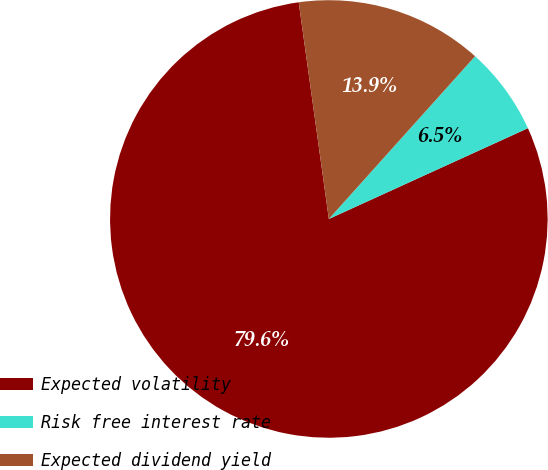<chart> <loc_0><loc_0><loc_500><loc_500><pie_chart><fcel>Expected volatility<fcel>Risk free interest rate<fcel>Expected dividend yield<nl><fcel>79.61%<fcel>6.54%<fcel>13.85%<nl></chart> 